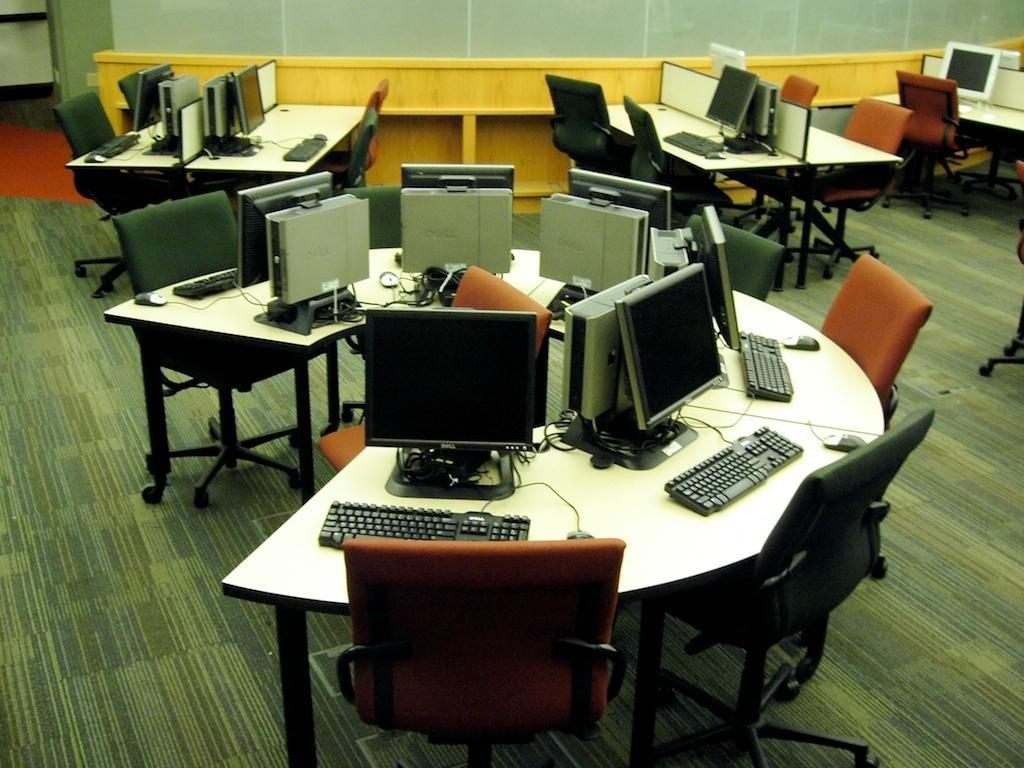Could you give a brief overview of what you see in this image? In this picture there are many computers arranged in a round table arranged with chairs of brown and green colors. In the background we also observe few tables on top of which monitors are placed. There is a wooden wall in the background. 